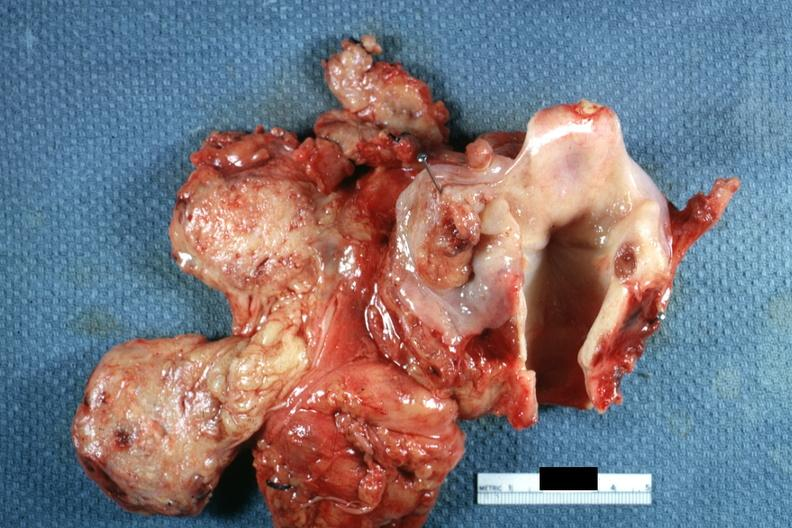where is this?
Answer the question using a single word or phrase. Oral 